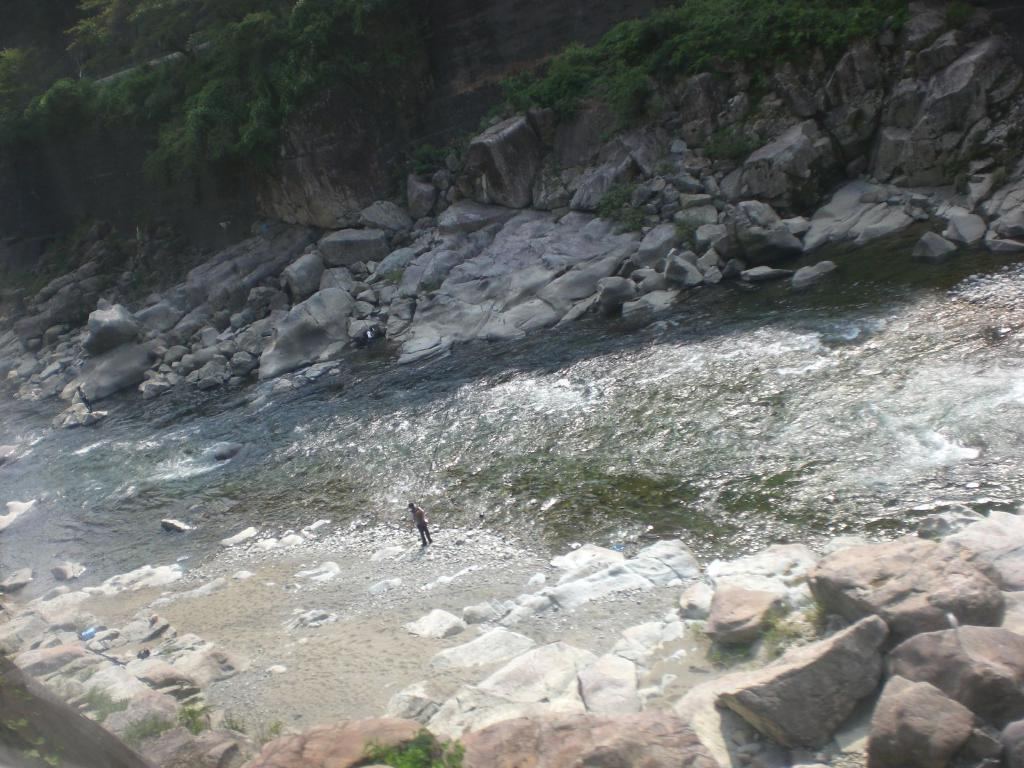Who or what is present in the image? There is a person in the image. What type of natural elements can be seen in the image? There are rocks and water visible in the image. What can be seen in the background of the image? There are trees in the background of the image. What type of organization does the secretary work for in the image? There is no secretary or organization present in the image. What causes the spark in the image? There is no spark present in the image. 